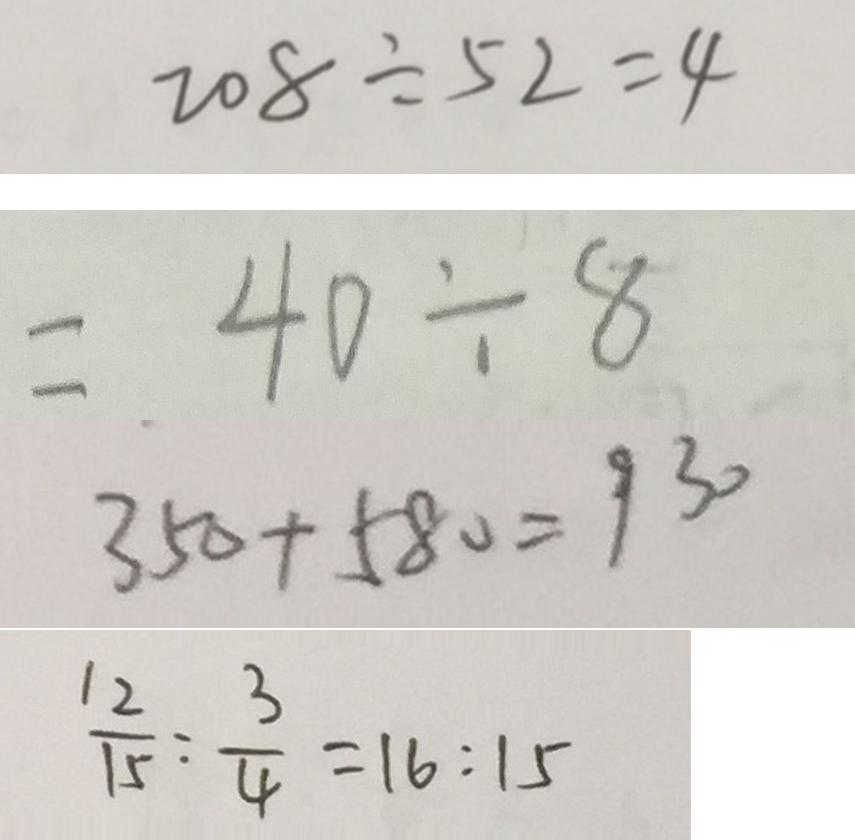<formula> <loc_0><loc_0><loc_500><loc_500>2 0 8 \div 5 2 = 4 
 = 4 0 \div 8 
 3 5 0 + 5 8 0 = 9 3 0 
 \frac { 1 2 } { 1 5 } : \frac { 3 } { 4 } = 1 6 : 1 5</formula> 